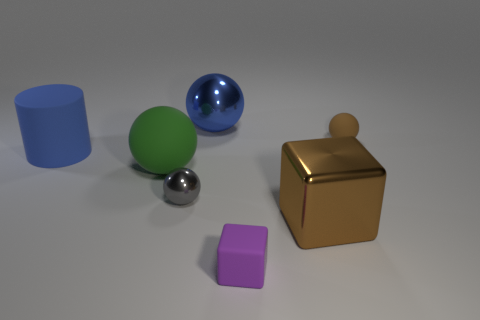Subtract all big green spheres. How many spheres are left? 3 Subtract all red spheres. Subtract all brown cubes. How many spheres are left? 4 Add 1 matte spheres. How many objects exist? 8 Subtract all cubes. How many objects are left? 5 Add 3 matte cubes. How many matte cubes exist? 4 Subtract 1 green balls. How many objects are left? 6 Subtract all brown rubber things. Subtract all large matte spheres. How many objects are left? 5 Add 6 large matte objects. How many large matte objects are left? 8 